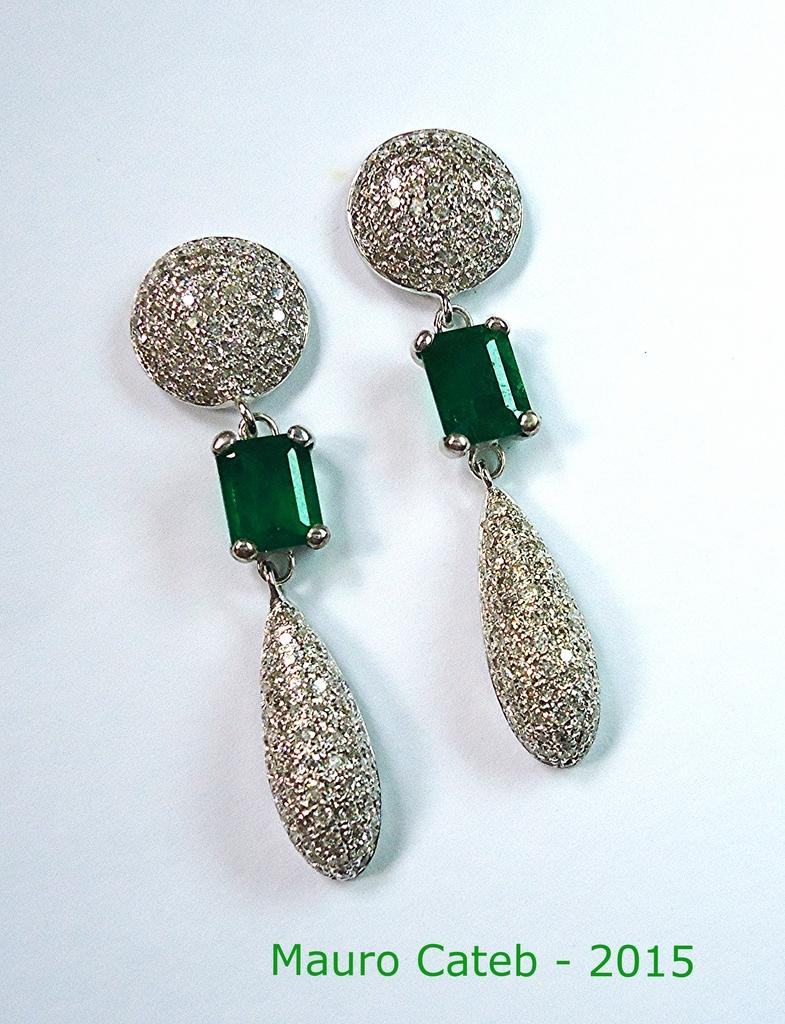What is the main subject of the image? The main subject of the image is a pair of earrings. Where are the earrings located in the image? The earrings are in the center of the image. What is the earrings' position in relation to the image? The earrings are on a surface. Is there any text present in the image? Yes, there is text at the bottom of the image. What type of beef is being cooked in the image? There is no beef present in the image; it features a pair of earrings on a surface with text at the bottom. Can you describe the burst of steam coming from the earrings in the image? There is no steam or burst present in the image; it only features a pair of earrings on a surface with text at the bottom. 